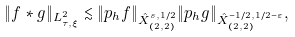<formula> <loc_0><loc_0><loc_500><loc_500>\| f * g \| _ { L _ { \tau , \xi } ^ { 2 } } \lesssim \| p _ { h } f \| _ { \hat { X } _ { ( 2 , 2 ) } ^ { s , 1 / 2 } } \| p _ { h } g \| _ { \hat { X } _ { ( 2 , 2 ) } ^ { - 1 / 2 , 1 / 2 - \varepsilon } } ,</formula> 